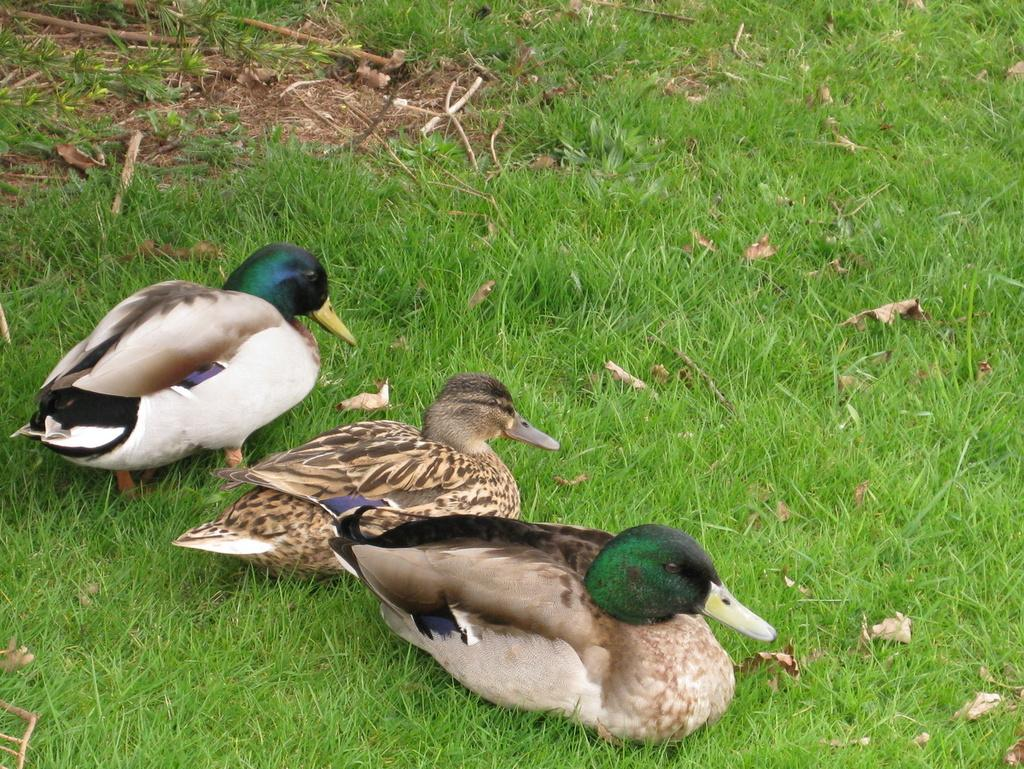What type of ground is visible in the image? There is grass ground in the image. What can be found on the grass ground? There are leaves on the grass ground. How many birds are present in the image? There are three birds in the image. Can you describe the colors of the birds? One bird has a white color, one bird has a green color, one bird has a black color, and one bird has a brown color. What message does the father give to the birds before they fly away in the image? There is no father or message present in the image; it only features birds and their colors. 